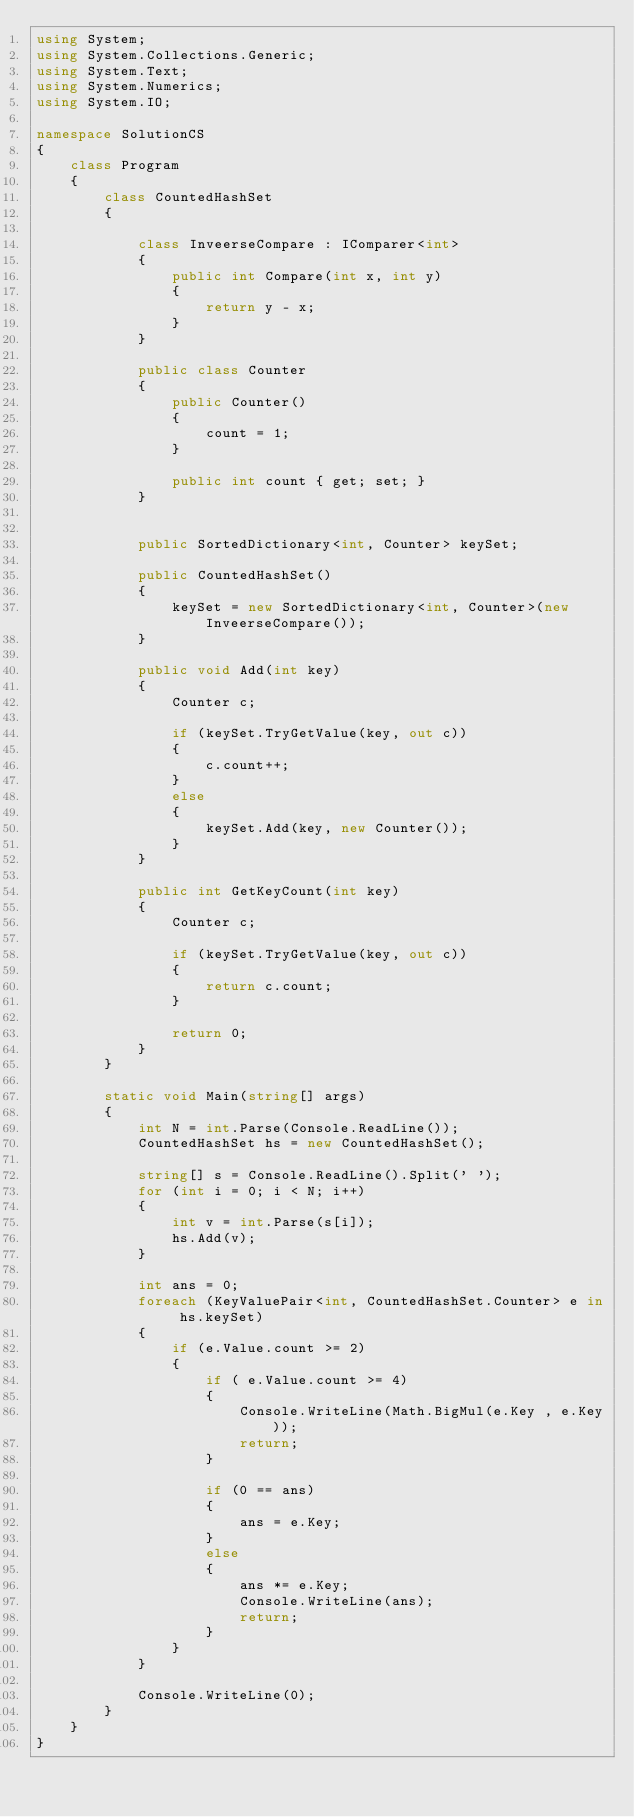<code> <loc_0><loc_0><loc_500><loc_500><_C#_>using System;
using System.Collections.Generic;
using System.Text;
using System.Numerics;
using System.IO;

namespace SolutionCS
{
    class Program
    {
        class CountedHashSet
        {

            class InveerseCompare : IComparer<int>
            {
                public int Compare(int x, int y)
                {
                    return y - x;
                }
            }

            public class Counter
            {
                public Counter()
                {
                    count = 1;
                }

                public int count { get; set; }
            }


            public SortedDictionary<int, Counter> keySet;

            public CountedHashSet()
            {
                keySet = new SortedDictionary<int, Counter>(new InveerseCompare());
            }

            public void Add(int key)
            {
                Counter c;

                if (keySet.TryGetValue(key, out c))
                {
                    c.count++;
                }
                else
                {
                    keySet.Add(key, new Counter());
                }
            }

            public int GetKeyCount(int key)
            {
                Counter c;

                if (keySet.TryGetValue(key, out c))
                {
                    return c.count;
                }

                return 0;
            }
        }

        static void Main(string[] args)
        {
            int N = int.Parse(Console.ReadLine());
            CountedHashSet hs = new CountedHashSet();

            string[] s = Console.ReadLine().Split(' ');
            for (int i = 0; i < N; i++)
            {
                int v = int.Parse(s[i]);
                hs.Add(v);
            }

            int ans = 0;
            foreach (KeyValuePair<int, CountedHashSet.Counter> e in hs.keySet)
            {
                if (e.Value.count >= 2)
                {
                    if ( e.Value.count >= 4)
                    {
                        Console.WriteLine(Math.BigMul(e.Key , e.Key));
                        return;
                    }

                    if (0 == ans)
                    {
                        ans = e.Key;
                    }
                    else
                    {
                        ans *= e.Key;
                        Console.WriteLine(ans);
                        return;
                    }
                }
            }

            Console.WriteLine(0);
        }
    }
}
</code> 